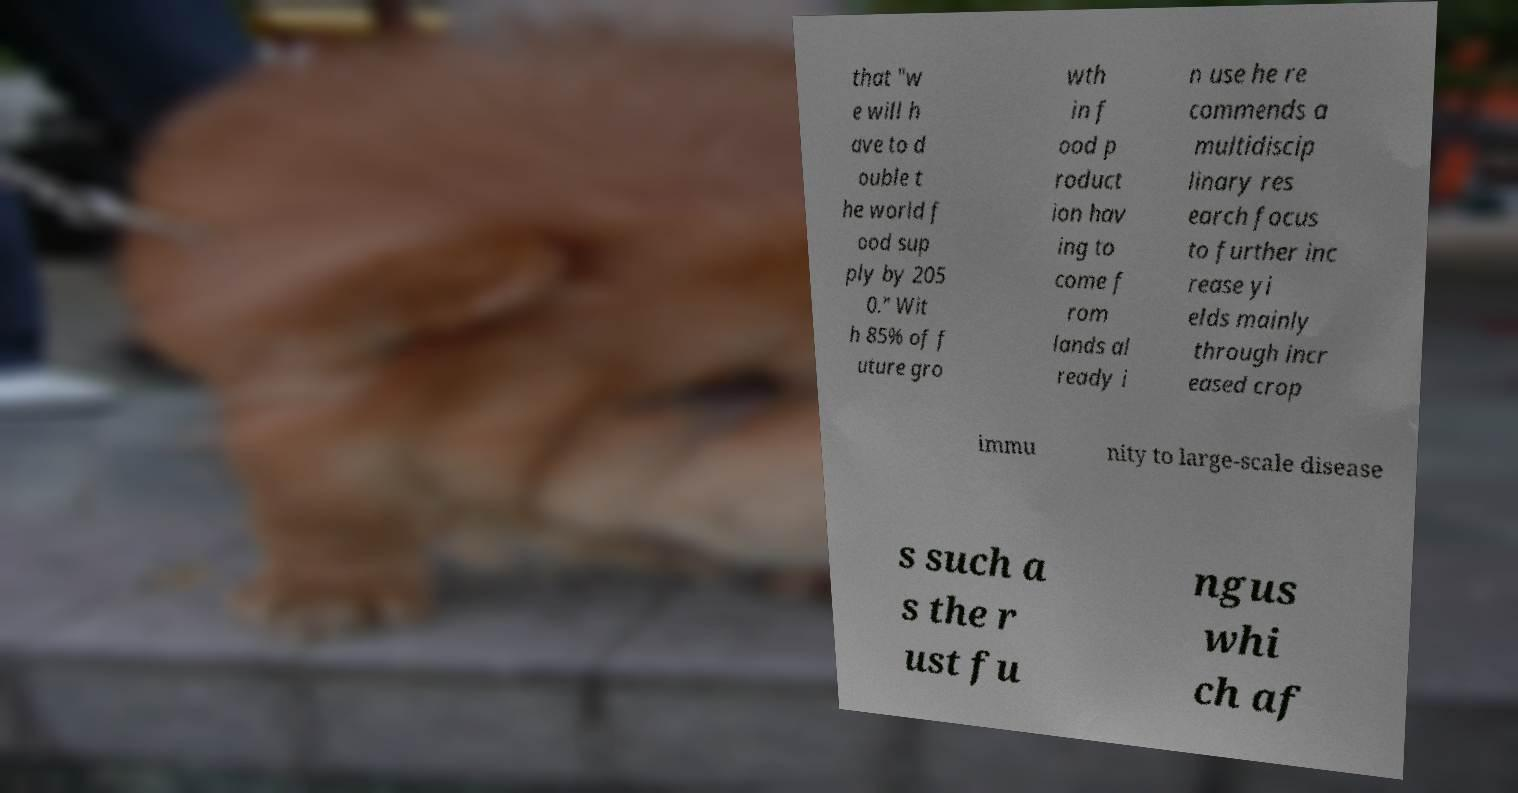What messages or text are displayed in this image? I need them in a readable, typed format. that "w e will h ave to d ouble t he world f ood sup ply by 205 0." Wit h 85% of f uture gro wth in f ood p roduct ion hav ing to come f rom lands al ready i n use he re commends a multidiscip linary res earch focus to further inc rease yi elds mainly through incr eased crop immu nity to large-scale disease s such a s the r ust fu ngus whi ch af 